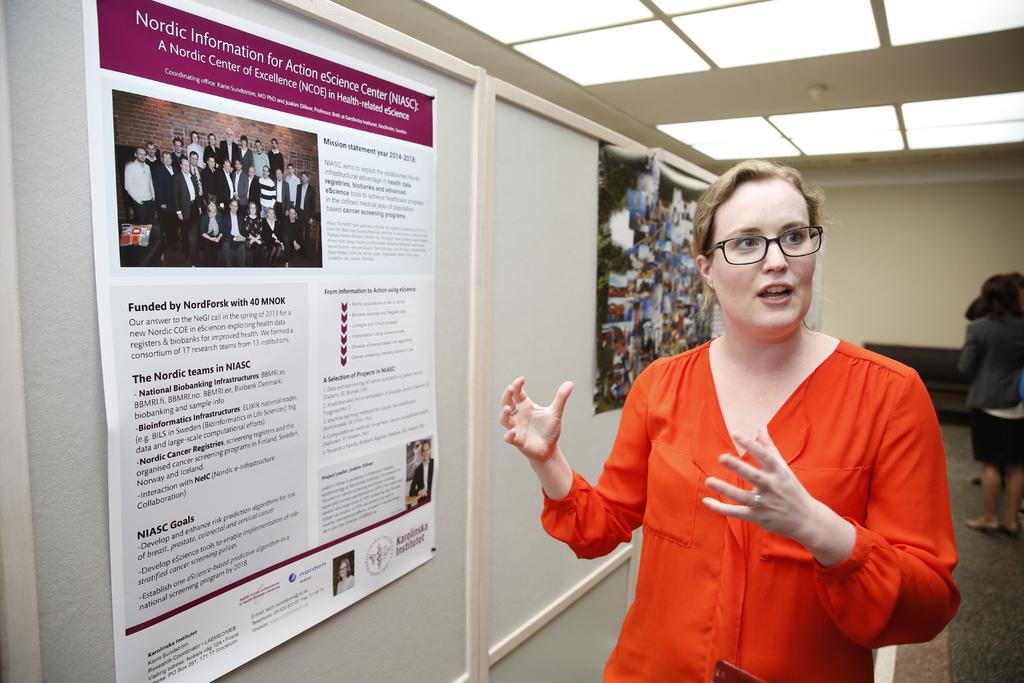What is the woman in the image doing? The woman is standing and talking. What can be seen on the wall in the image? There is a banner and a board on the wall. What is visible in the background of the image? In the background, there are people, a wall, and a sofa. What is present at the top of the image? There is a ceiling at the top of the image. What can be seen on the ceiling? There are lights on the ceiling. What type of fruit is being used as a decoration on the sofa in the image? There is no fruit present in the image, and the sofa is not being used as a decoration. 